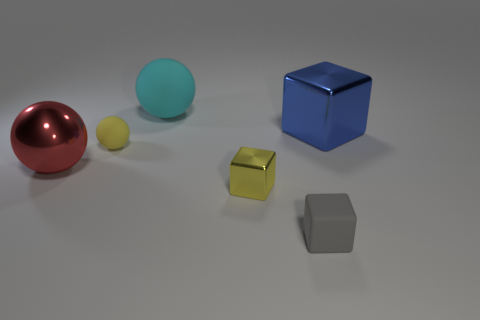The cyan matte thing that is the same shape as the red thing is what size? The cyan object, which shares the same spherical shape as the red object, appears to be of medium size relative to the other items in the image. 